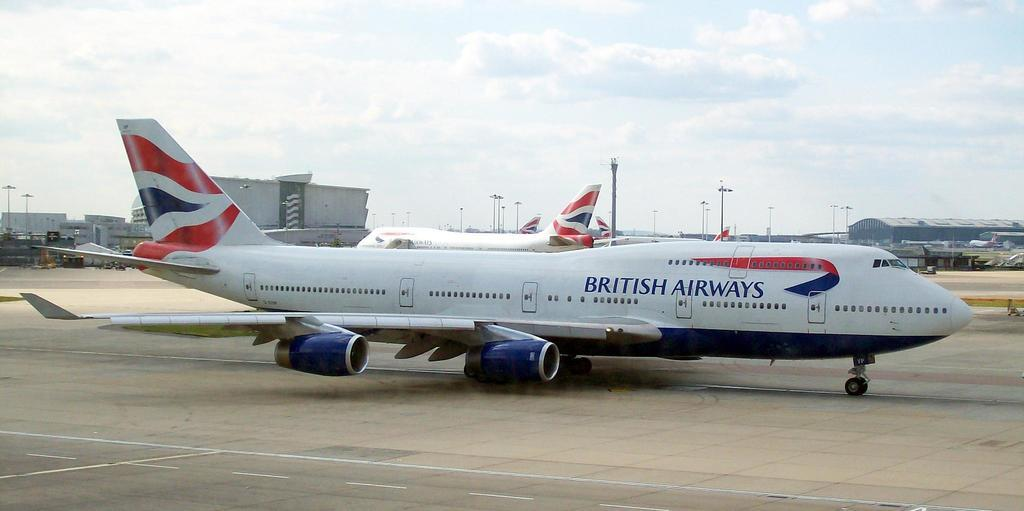<image>
Summarize the visual content of the image. the british airways plane is sitting on the field with other planes 